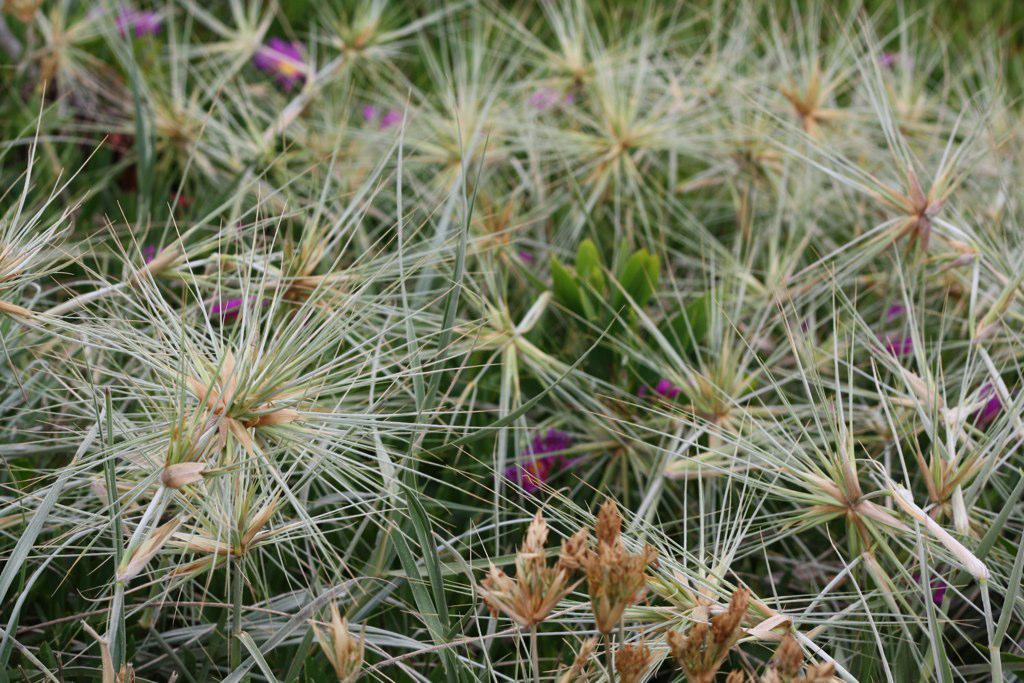What types of vegetation are present in the image? There are many plants in the image. What features can be observed on the plants? The plants have leaves and flowers. What color is the plant's desire to expand in the image? There is no indication of a plant's desire to expand in the image, and therefore no color can be assigned to it. 